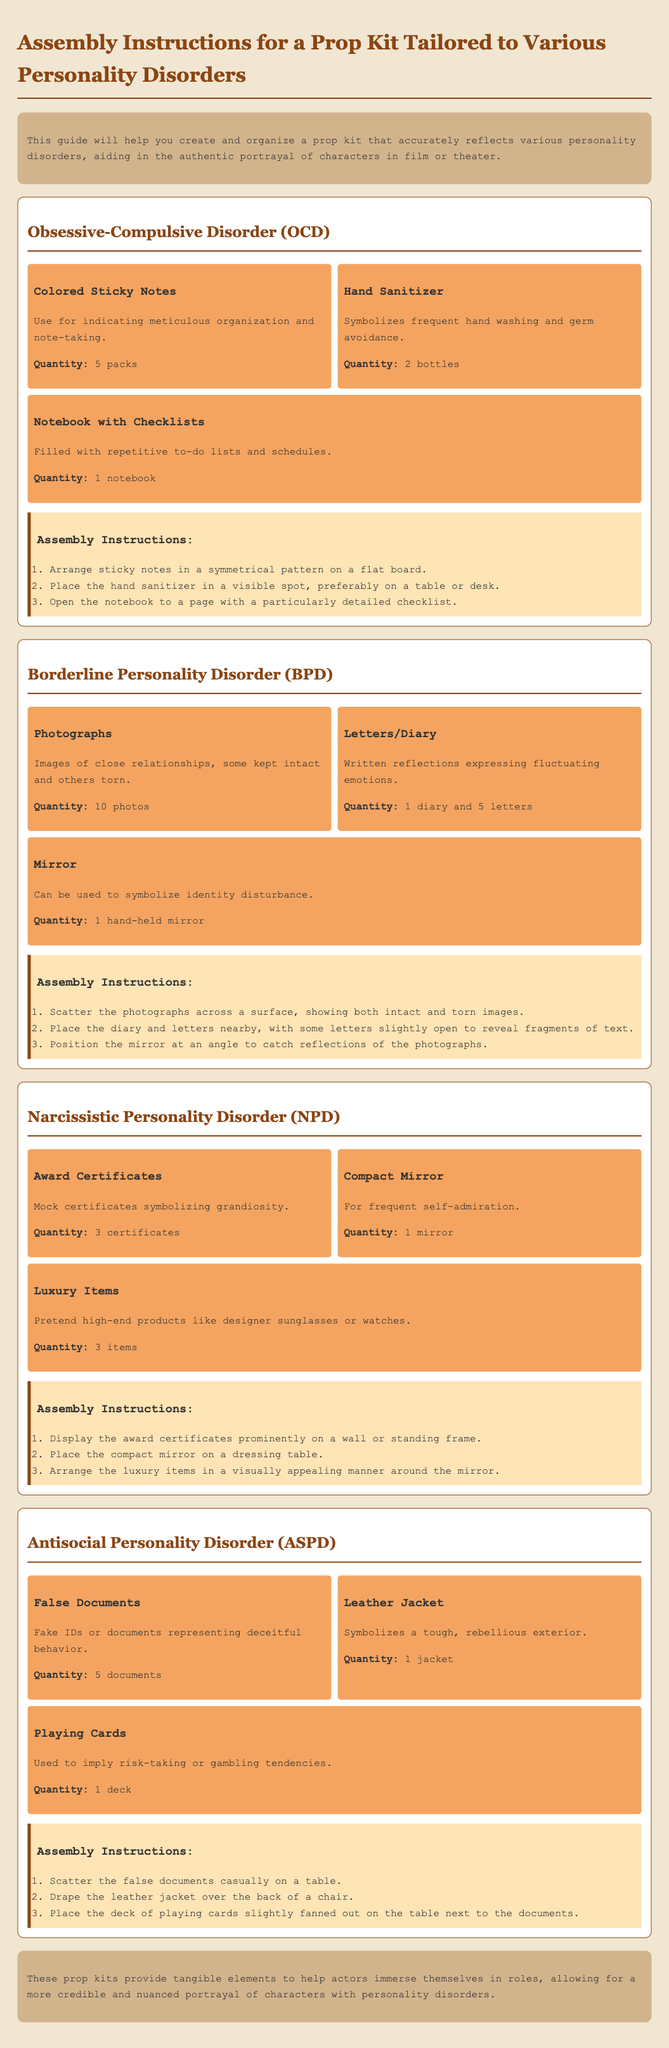What are the three props for OCD? The props listed for OCD are Colored Sticky Notes, Hand Sanitizer, and Notebook with Checklists.
Answer: Colored Sticky Notes, Hand Sanitizer, Notebook with Checklists How many photographs are needed for BPD? The document states that 10 photographs are required for BPD.
Answer: 10 photos What item symbolizes self-admiration for NPD? The compact mirror is used to symbolize frequent self-admiration for NPD.
Answer: Compact Mirror What is the quantity of letters mentioned for BPD? The assembly instructions specify that there should be 5 letters for BPD.
Answer: 5 letters What are the assembly instructions for the mirror in BPD? The instructions state to position the mirror at an angle to catch reflections of the photographs.
Answer: At an angle to catch reflections of the photographs How many false documents are required for ASPD? The document indicates that 5 false documents are needed for ASPD.
Answer: 5 documents Which prop indicates meticulous organization? The colored sticky notes are used to indicate meticulous organization in the portrayal of OCD.
Answer: Colored Sticky Notes How should the luxury items be arranged for NPD? The instructions suggest arranging the luxury items in a visually appealing manner around the mirror.
Answer: Visually appealing manner around the mirror 